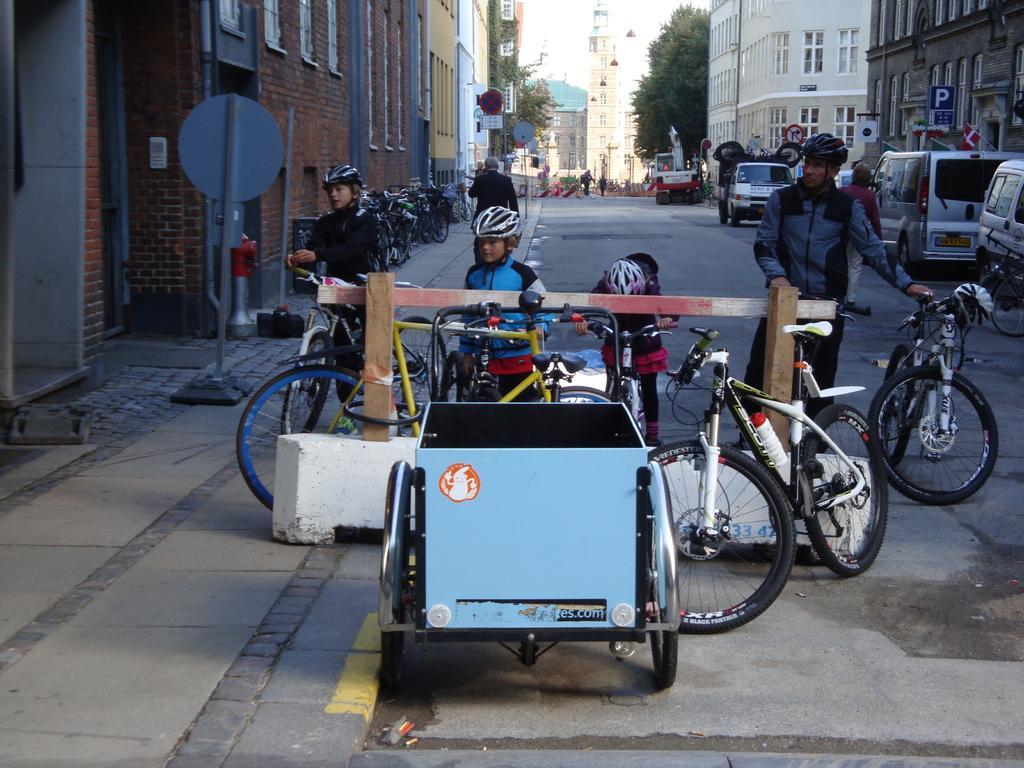Please provide a concise description of this image. In this image in the center there are some people who are standing and they are holding cycles and also they are wearing helmets. On the right side and left side there are some buildings, trees and some vehicles. On the left side there is one footpath, on the footpath there is one person who is walking and there are some cycles which are parked. In the background there are some buildings, trees and some other vehicles. At the bottom there is a road. 